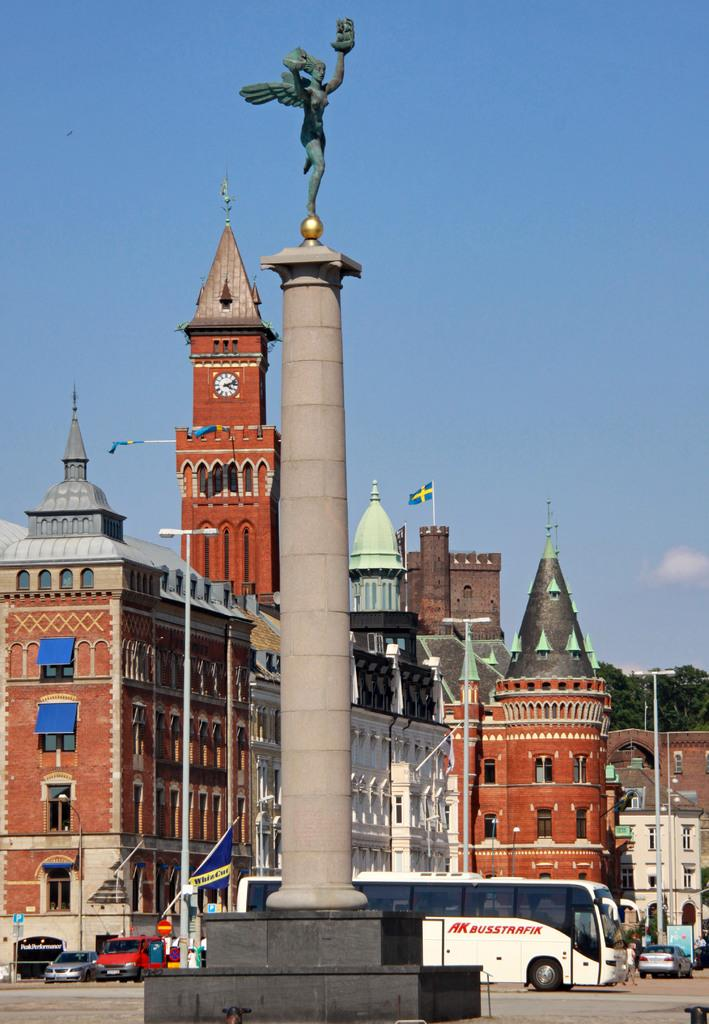What is the main subject in the middle of the image? There is a statue in the middle of the image. What can be seen in the background of the image? There are buildings visible in the background of the image. What type of pet is sitting next to the statue in the image? There is no pet present in the image; it only features a statue and buildings in the background. 